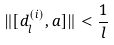Convert formula to latex. <formula><loc_0><loc_0><loc_500><loc_500>\| [ d _ { l } ^ { ( i ) } , a ] \| < \frac { 1 } { l }</formula> 